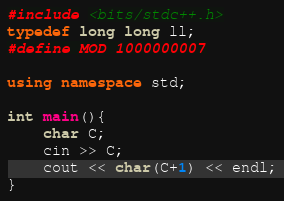Convert code to text. <code><loc_0><loc_0><loc_500><loc_500><_C++_>#include <bits/stdc++.h>
typedef long long ll;
#define MOD 1000000007
 
using namespace std;
 
int main(){
    char C;
    cin >> C;
    cout << char(C+1) << endl;
}</code> 